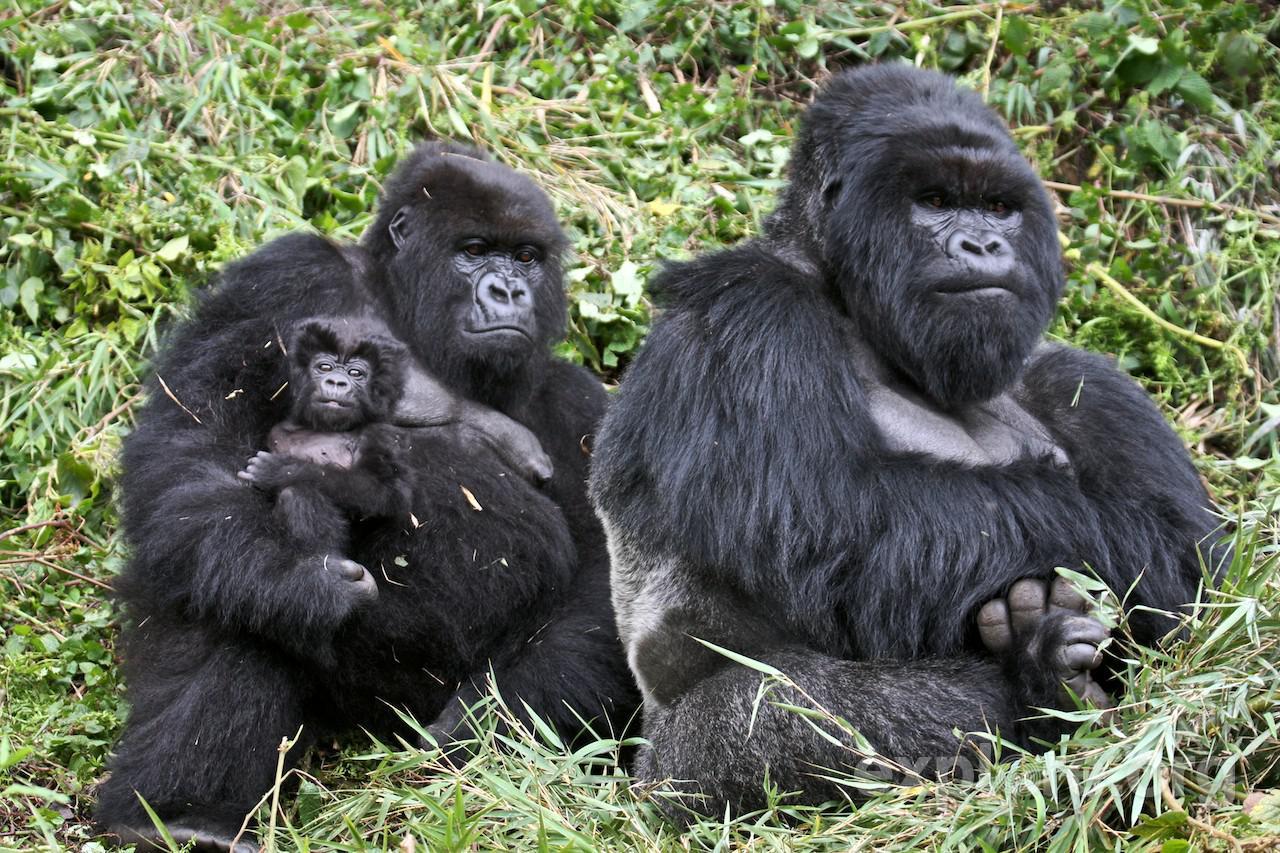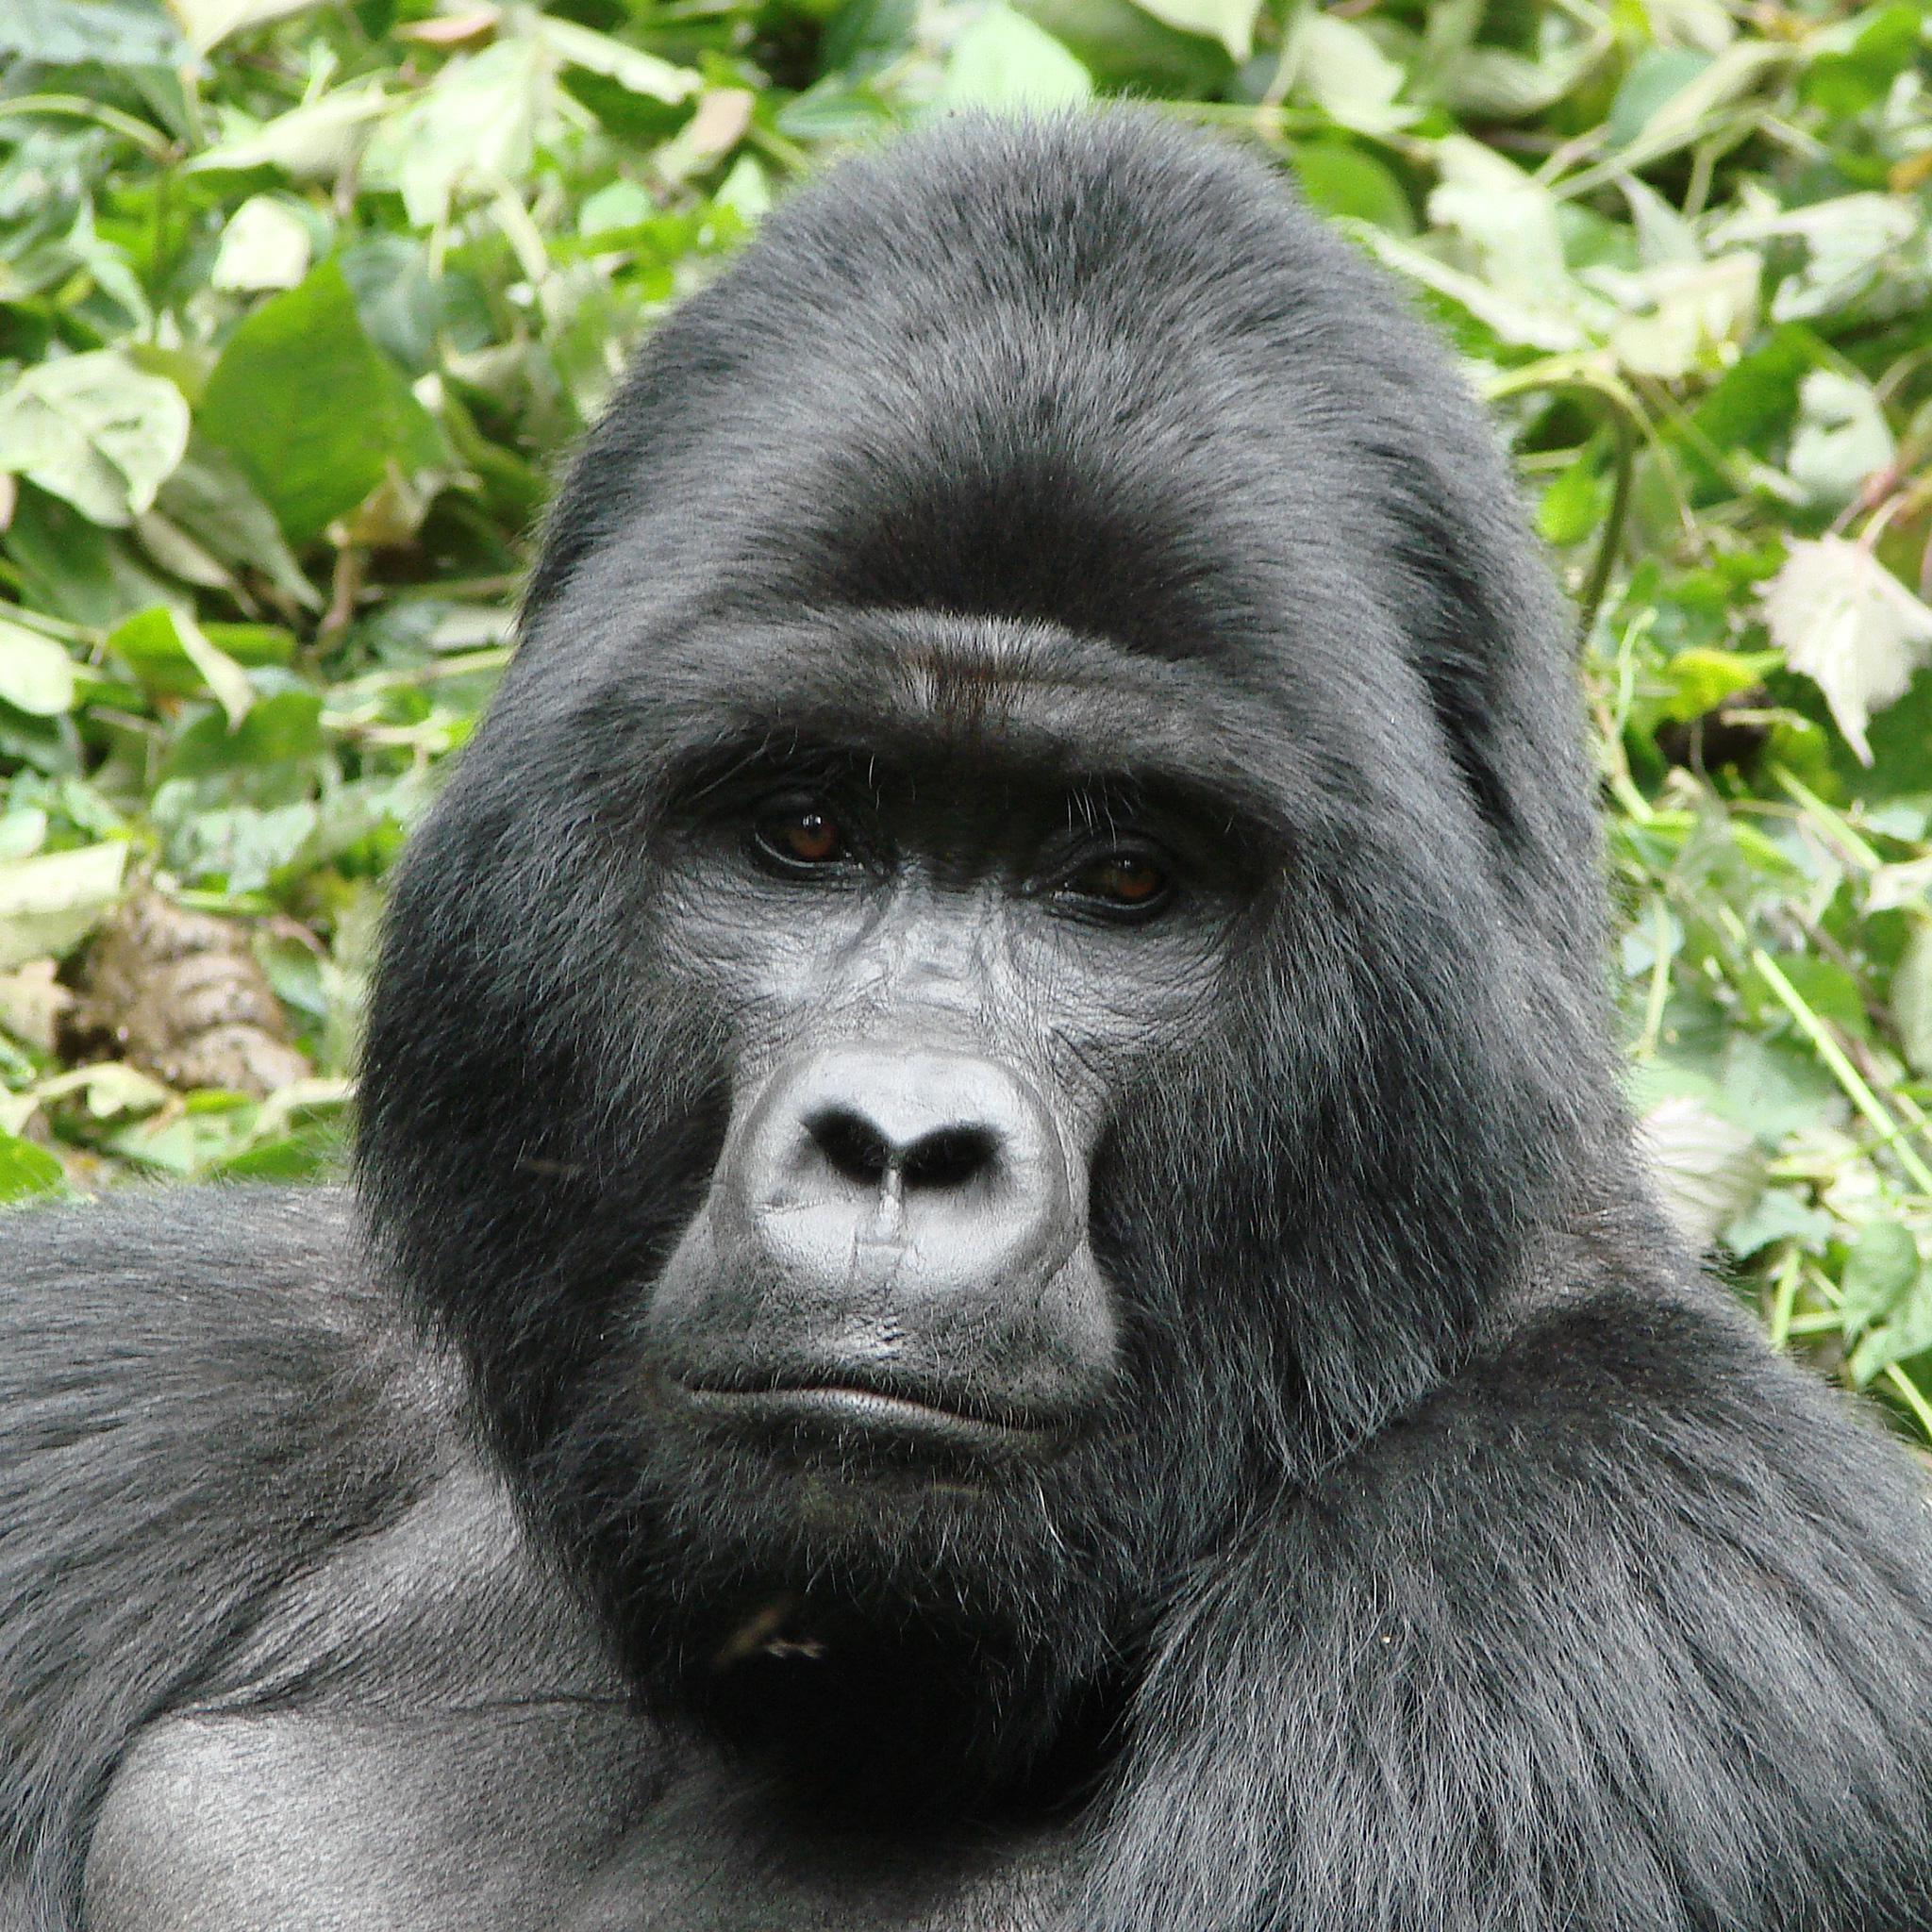The first image is the image on the left, the second image is the image on the right. Given the left and right images, does the statement "An image shows three gorillas of different sizes." hold true? Answer yes or no. Yes. The first image is the image on the left, the second image is the image on the right. Given the left and right images, does the statement "There is exactly one animal in the image on the left." hold true? Answer yes or no. No. 